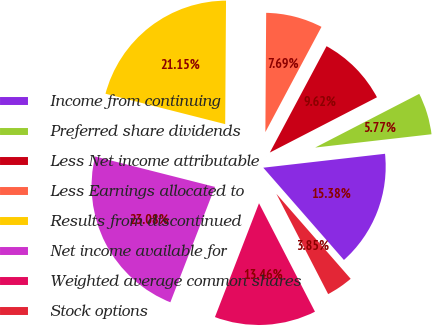Convert chart. <chart><loc_0><loc_0><loc_500><loc_500><pie_chart><fcel>Income from continuing<fcel>Preferred share dividends<fcel>Less Net income attributable<fcel>Less Earnings allocated to<fcel>Results from discontinued<fcel>Net income available for<fcel>Weighted average common shares<fcel>Stock options<nl><fcel>15.38%<fcel>5.77%<fcel>9.62%<fcel>7.69%<fcel>21.15%<fcel>23.08%<fcel>13.46%<fcel>3.85%<nl></chart> 